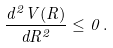<formula> <loc_0><loc_0><loc_500><loc_500>\frac { d ^ { 2 } V ( R ) } { d R ^ { 2 } } \leq 0 \, .</formula> 